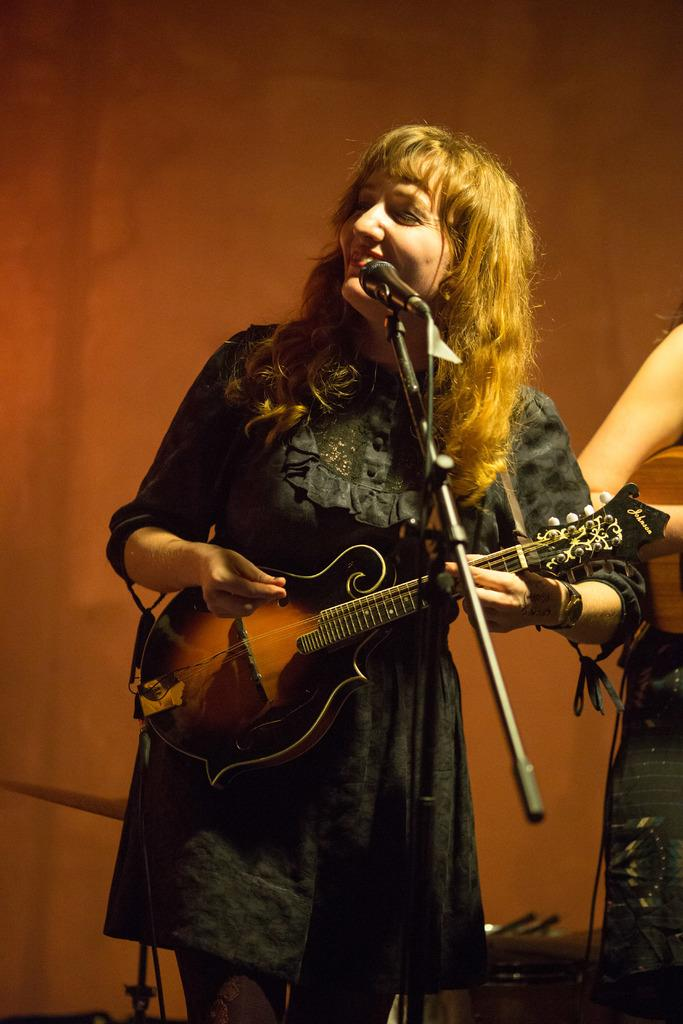Who is the main subject in the picture? There is a woman in the picture. What is the woman doing in the image? The woman is playing a guitar and standing in front of a microphone. How does the woman appear in the image? The woman is holding a pretty smile on her face. What type of oil can be seen dripping from the guitar in the image? There is no oil present in the image, and the guitar is not shown dripping anything. 